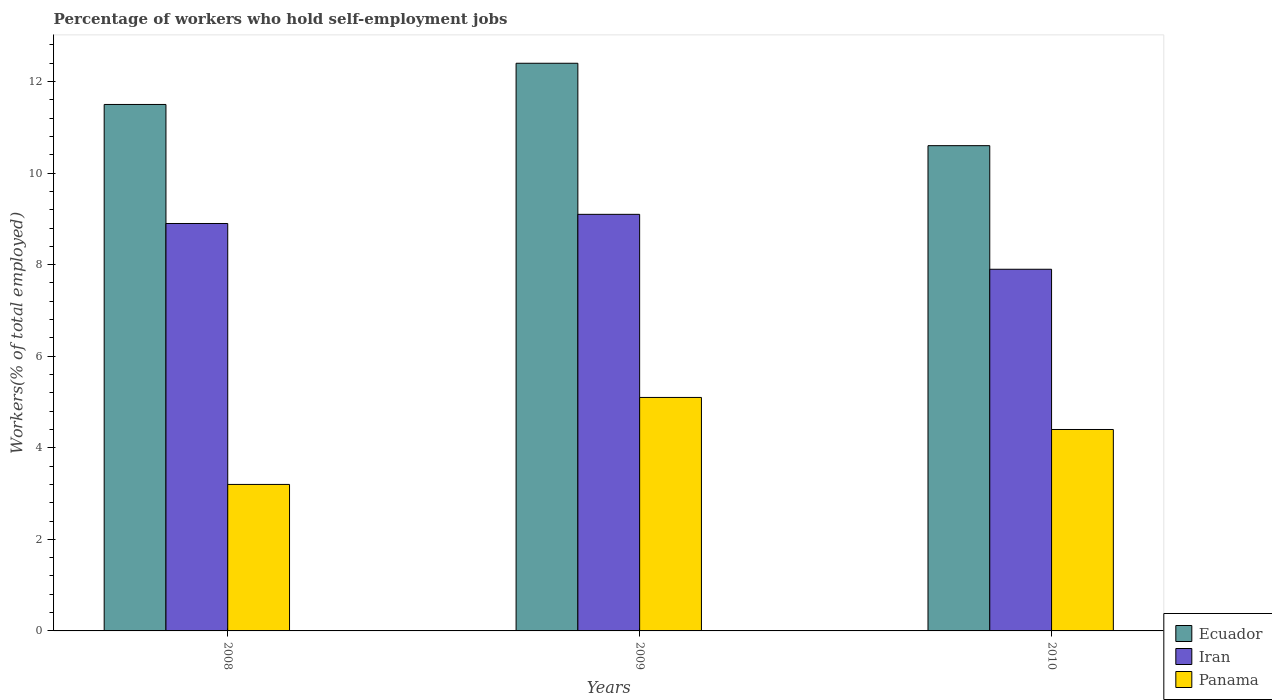How many different coloured bars are there?
Your response must be concise. 3. How many groups of bars are there?
Your answer should be very brief. 3. Are the number of bars per tick equal to the number of legend labels?
Provide a succinct answer. Yes. How many bars are there on the 2nd tick from the left?
Ensure brevity in your answer.  3. How many bars are there on the 2nd tick from the right?
Provide a short and direct response. 3. In how many cases, is the number of bars for a given year not equal to the number of legend labels?
Your answer should be compact. 0. What is the percentage of self-employed workers in Panama in 2010?
Make the answer very short. 4.4. Across all years, what is the maximum percentage of self-employed workers in Ecuador?
Provide a short and direct response. 12.4. Across all years, what is the minimum percentage of self-employed workers in Panama?
Provide a succinct answer. 3.2. In which year was the percentage of self-employed workers in Panama maximum?
Ensure brevity in your answer.  2009. In which year was the percentage of self-employed workers in Iran minimum?
Offer a very short reply. 2010. What is the total percentage of self-employed workers in Iran in the graph?
Provide a short and direct response. 25.9. What is the difference between the percentage of self-employed workers in Ecuador in 2008 and that in 2009?
Give a very brief answer. -0.9. What is the difference between the percentage of self-employed workers in Ecuador in 2010 and the percentage of self-employed workers in Panama in 2009?
Provide a succinct answer. 5.5. What is the average percentage of self-employed workers in Ecuador per year?
Your answer should be compact. 11.5. In the year 2009, what is the difference between the percentage of self-employed workers in Ecuador and percentage of self-employed workers in Iran?
Give a very brief answer. 3.3. What is the ratio of the percentage of self-employed workers in Iran in 2008 to that in 2009?
Offer a terse response. 0.98. What is the difference between the highest and the second highest percentage of self-employed workers in Iran?
Your response must be concise. 0.2. What is the difference between the highest and the lowest percentage of self-employed workers in Ecuador?
Keep it short and to the point. 1.8. What does the 1st bar from the left in 2010 represents?
Provide a succinct answer. Ecuador. What does the 3rd bar from the right in 2009 represents?
Keep it short and to the point. Ecuador. Are all the bars in the graph horizontal?
Your answer should be compact. No. How many legend labels are there?
Your answer should be compact. 3. What is the title of the graph?
Your answer should be very brief. Percentage of workers who hold self-employment jobs. Does "Mauritius" appear as one of the legend labels in the graph?
Make the answer very short. No. What is the label or title of the Y-axis?
Your response must be concise. Workers(% of total employed). What is the Workers(% of total employed) of Ecuador in 2008?
Provide a short and direct response. 11.5. What is the Workers(% of total employed) in Iran in 2008?
Your answer should be compact. 8.9. What is the Workers(% of total employed) of Panama in 2008?
Offer a very short reply. 3.2. What is the Workers(% of total employed) in Ecuador in 2009?
Make the answer very short. 12.4. What is the Workers(% of total employed) of Iran in 2009?
Your answer should be very brief. 9.1. What is the Workers(% of total employed) in Panama in 2009?
Ensure brevity in your answer.  5.1. What is the Workers(% of total employed) of Ecuador in 2010?
Ensure brevity in your answer.  10.6. What is the Workers(% of total employed) in Iran in 2010?
Provide a succinct answer. 7.9. What is the Workers(% of total employed) in Panama in 2010?
Make the answer very short. 4.4. Across all years, what is the maximum Workers(% of total employed) in Ecuador?
Your answer should be compact. 12.4. Across all years, what is the maximum Workers(% of total employed) of Iran?
Keep it short and to the point. 9.1. Across all years, what is the maximum Workers(% of total employed) in Panama?
Give a very brief answer. 5.1. Across all years, what is the minimum Workers(% of total employed) of Ecuador?
Offer a terse response. 10.6. Across all years, what is the minimum Workers(% of total employed) of Iran?
Your response must be concise. 7.9. Across all years, what is the minimum Workers(% of total employed) of Panama?
Offer a terse response. 3.2. What is the total Workers(% of total employed) in Ecuador in the graph?
Offer a very short reply. 34.5. What is the total Workers(% of total employed) in Iran in the graph?
Provide a succinct answer. 25.9. What is the total Workers(% of total employed) of Panama in the graph?
Provide a succinct answer. 12.7. What is the difference between the Workers(% of total employed) in Iran in 2008 and that in 2009?
Give a very brief answer. -0.2. What is the difference between the Workers(% of total employed) in Ecuador in 2008 and that in 2010?
Provide a succinct answer. 0.9. What is the difference between the Workers(% of total employed) of Iran in 2008 and that in 2010?
Ensure brevity in your answer.  1. What is the difference between the Workers(% of total employed) of Ecuador in 2009 and that in 2010?
Ensure brevity in your answer.  1.8. What is the difference between the Workers(% of total employed) of Ecuador in 2008 and the Workers(% of total employed) of Panama in 2009?
Provide a succinct answer. 6.4. What is the difference between the Workers(% of total employed) of Iran in 2008 and the Workers(% of total employed) of Panama in 2009?
Offer a very short reply. 3.8. What is the difference between the Workers(% of total employed) in Ecuador in 2008 and the Workers(% of total employed) in Panama in 2010?
Provide a succinct answer. 7.1. What is the difference between the Workers(% of total employed) of Iran in 2008 and the Workers(% of total employed) of Panama in 2010?
Your response must be concise. 4.5. What is the difference between the Workers(% of total employed) in Ecuador in 2009 and the Workers(% of total employed) in Panama in 2010?
Make the answer very short. 8. What is the difference between the Workers(% of total employed) of Iran in 2009 and the Workers(% of total employed) of Panama in 2010?
Give a very brief answer. 4.7. What is the average Workers(% of total employed) of Ecuador per year?
Ensure brevity in your answer.  11.5. What is the average Workers(% of total employed) in Iran per year?
Give a very brief answer. 8.63. What is the average Workers(% of total employed) in Panama per year?
Ensure brevity in your answer.  4.23. In the year 2008, what is the difference between the Workers(% of total employed) in Ecuador and Workers(% of total employed) in Panama?
Provide a short and direct response. 8.3. In the year 2008, what is the difference between the Workers(% of total employed) of Iran and Workers(% of total employed) of Panama?
Ensure brevity in your answer.  5.7. In the year 2009, what is the difference between the Workers(% of total employed) of Ecuador and Workers(% of total employed) of Iran?
Your answer should be very brief. 3.3. In the year 2009, what is the difference between the Workers(% of total employed) in Ecuador and Workers(% of total employed) in Panama?
Provide a short and direct response. 7.3. In the year 2010, what is the difference between the Workers(% of total employed) in Ecuador and Workers(% of total employed) in Iran?
Provide a succinct answer. 2.7. In the year 2010, what is the difference between the Workers(% of total employed) of Iran and Workers(% of total employed) of Panama?
Offer a terse response. 3.5. What is the ratio of the Workers(% of total employed) in Ecuador in 2008 to that in 2009?
Ensure brevity in your answer.  0.93. What is the ratio of the Workers(% of total employed) in Panama in 2008 to that in 2009?
Provide a succinct answer. 0.63. What is the ratio of the Workers(% of total employed) in Ecuador in 2008 to that in 2010?
Offer a very short reply. 1.08. What is the ratio of the Workers(% of total employed) of Iran in 2008 to that in 2010?
Your response must be concise. 1.13. What is the ratio of the Workers(% of total employed) of Panama in 2008 to that in 2010?
Your response must be concise. 0.73. What is the ratio of the Workers(% of total employed) in Ecuador in 2009 to that in 2010?
Your answer should be compact. 1.17. What is the ratio of the Workers(% of total employed) of Iran in 2009 to that in 2010?
Your response must be concise. 1.15. What is the ratio of the Workers(% of total employed) of Panama in 2009 to that in 2010?
Offer a very short reply. 1.16. What is the difference between the highest and the second highest Workers(% of total employed) in Panama?
Your answer should be very brief. 0.7. 